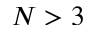Convert formula to latex. <formula><loc_0><loc_0><loc_500><loc_500>N > 3</formula> 